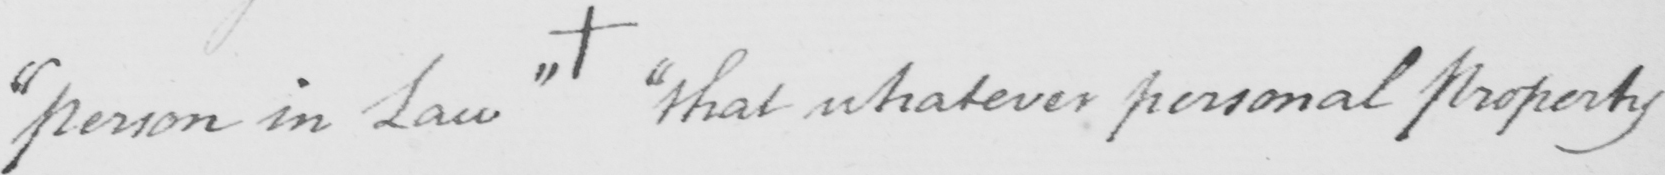What text is written in this handwritten line? " person in Law "   +   " that whatever personal property 